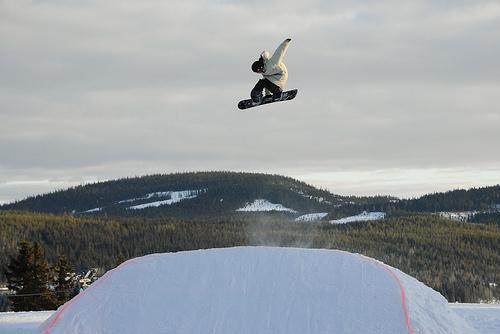How many people are pictured?
Give a very brief answer. 1. 